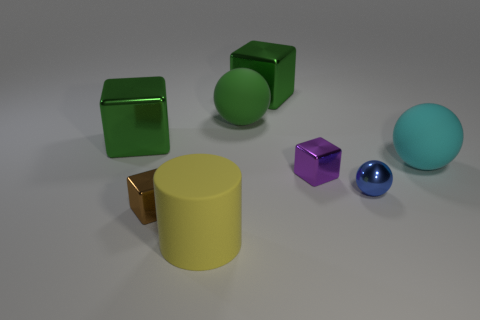What color is the rubber cylinder that is the same size as the cyan rubber object? yellow 